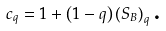Convert formula to latex. <formula><loc_0><loc_0><loc_500><loc_500>c _ { q } = 1 + \left ( 1 - q \right ) \left ( S _ { B } \right ) _ { q } \text {.}</formula> 